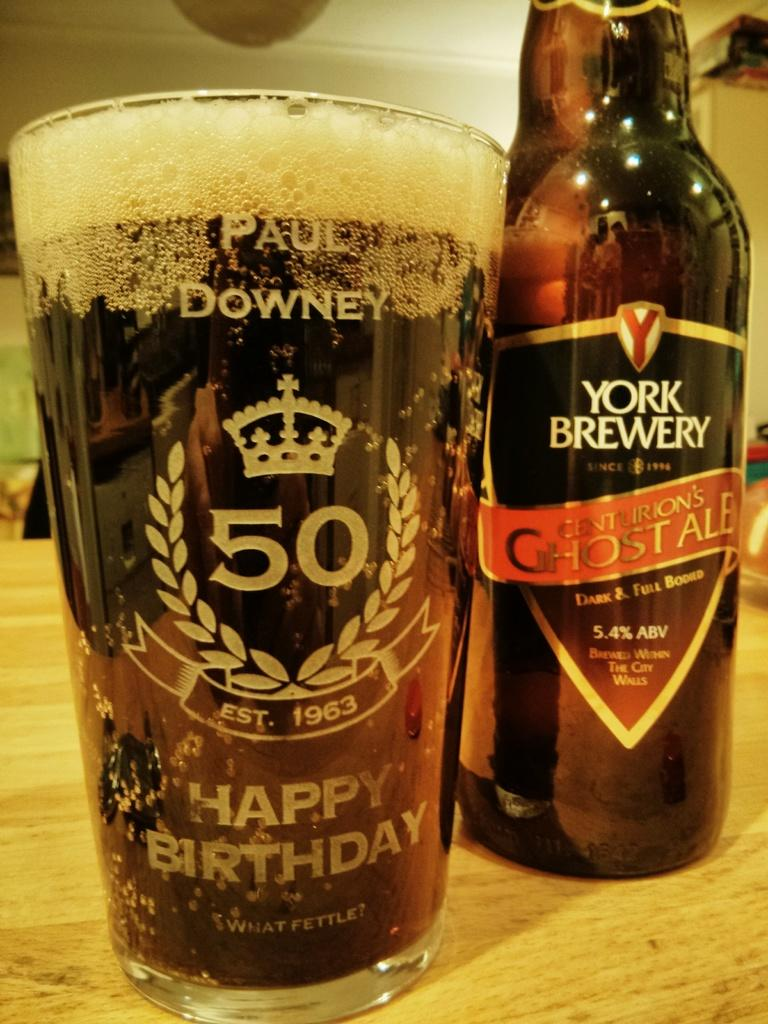Provide a one-sentence caption for the provided image. A cup of beer that says happy birthday on it. 